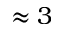Convert formula to latex. <formula><loc_0><loc_0><loc_500><loc_500>\approx 3</formula> 